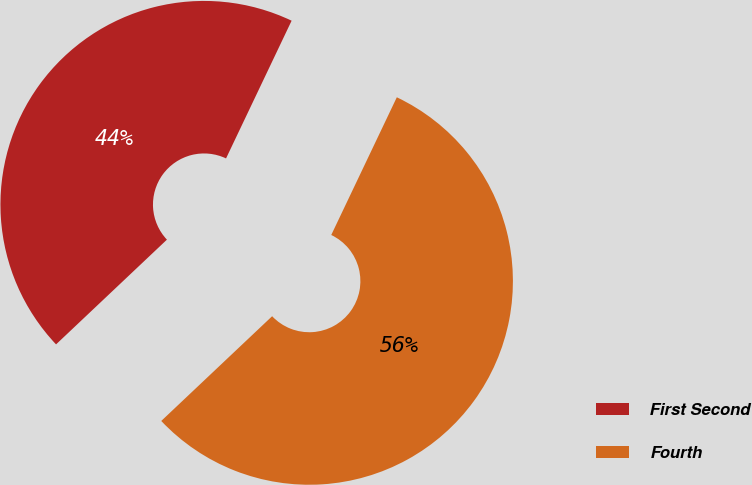Convert chart to OTSL. <chart><loc_0><loc_0><loc_500><loc_500><pie_chart><fcel>First Second<fcel>Fourth<nl><fcel>44.12%<fcel>55.88%<nl></chart> 